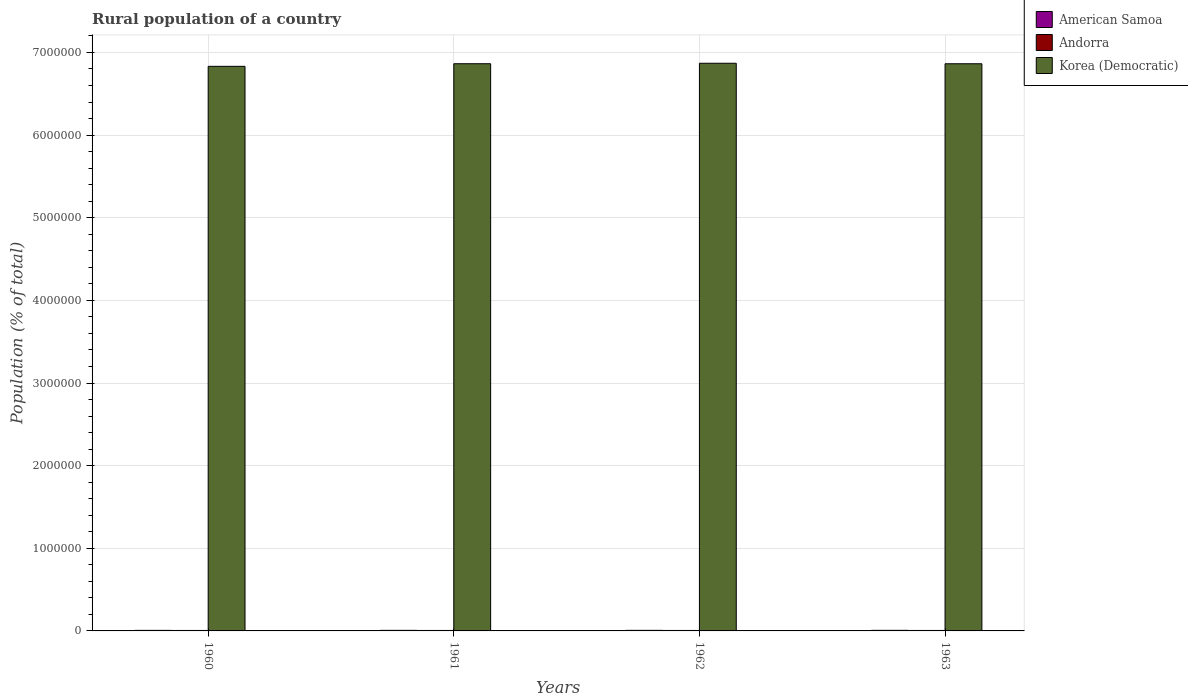How many groups of bars are there?
Provide a succinct answer. 4. Are the number of bars on each tick of the X-axis equal?
Ensure brevity in your answer.  Yes. How many bars are there on the 4th tick from the left?
Keep it short and to the point. 3. What is the label of the 1st group of bars from the left?
Provide a short and direct response. 1960. In how many cases, is the number of bars for a given year not equal to the number of legend labels?
Make the answer very short. 0. What is the rural population in Korea (Democratic) in 1963?
Provide a succinct answer. 6.86e+06. Across all years, what is the maximum rural population in Andorra?
Provide a short and direct response. 5618. Across all years, what is the minimum rural population in American Samoa?
Your answer should be compact. 6762. What is the total rural population in Andorra in the graph?
Your answer should be very brief. 2.24e+04. What is the difference between the rural population in Korea (Democratic) in 1960 and that in 1961?
Keep it short and to the point. -3.16e+04. What is the difference between the rural population in Korea (Democratic) in 1963 and the rural population in Andorra in 1960?
Keep it short and to the point. 6.86e+06. What is the average rural population in Korea (Democratic) per year?
Give a very brief answer. 6.86e+06. In the year 1962, what is the difference between the rural population in Andorra and rural population in Korea (Democratic)?
Make the answer very short. -6.86e+06. What is the ratio of the rural population in Korea (Democratic) in 1962 to that in 1963?
Make the answer very short. 1. Is the rural population in Andorra in 1960 less than that in 1963?
Provide a short and direct response. Yes. Is the difference between the rural population in Andorra in 1960 and 1963 greater than the difference between the rural population in Korea (Democratic) in 1960 and 1963?
Offer a very short reply. Yes. What is the difference between the highest and the second highest rural population in American Samoa?
Ensure brevity in your answer.  159. What is the difference between the highest and the lowest rural population in Andorra?
Offer a terse response. 44. Is the sum of the rural population in American Samoa in 1962 and 1963 greater than the maximum rural population in Korea (Democratic) across all years?
Keep it short and to the point. No. What does the 2nd bar from the left in 1963 represents?
Your response must be concise. Andorra. What does the 2nd bar from the right in 1961 represents?
Give a very brief answer. Andorra. How many bars are there?
Offer a terse response. 12. How many years are there in the graph?
Make the answer very short. 4. Does the graph contain any zero values?
Give a very brief answer. No. What is the title of the graph?
Provide a succinct answer. Rural population of a country. Does "Pacific island small states" appear as one of the legend labels in the graph?
Provide a short and direct response. No. What is the label or title of the Y-axis?
Your response must be concise. Population (% of total). What is the Population (% of total) of American Samoa in 1960?
Offer a terse response. 6762. What is the Population (% of total) of Andorra in 1960?
Give a very brief answer. 5574. What is the Population (% of total) of Korea (Democratic) in 1960?
Keep it short and to the point. 6.83e+06. What is the Population (% of total) in American Samoa in 1961?
Your response must be concise. 6831. What is the Population (% of total) of Andorra in 1961?
Your answer should be very brief. 5609. What is the Population (% of total) in Korea (Democratic) in 1961?
Offer a very short reply. 6.86e+06. What is the Population (% of total) of American Samoa in 1962?
Offer a very short reply. 6955. What is the Population (% of total) of Andorra in 1962?
Keep it short and to the point. 5618. What is the Population (% of total) in Korea (Democratic) in 1962?
Ensure brevity in your answer.  6.87e+06. What is the Population (% of total) of American Samoa in 1963?
Provide a short and direct response. 7114. What is the Population (% of total) of Andorra in 1963?
Your answer should be compact. 5600. What is the Population (% of total) in Korea (Democratic) in 1963?
Offer a very short reply. 6.86e+06. Across all years, what is the maximum Population (% of total) in American Samoa?
Offer a very short reply. 7114. Across all years, what is the maximum Population (% of total) in Andorra?
Your response must be concise. 5618. Across all years, what is the maximum Population (% of total) in Korea (Democratic)?
Keep it short and to the point. 6.87e+06. Across all years, what is the minimum Population (% of total) in American Samoa?
Keep it short and to the point. 6762. Across all years, what is the minimum Population (% of total) of Andorra?
Provide a succinct answer. 5574. Across all years, what is the minimum Population (% of total) of Korea (Democratic)?
Give a very brief answer. 6.83e+06. What is the total Population (% of total) in American Samoa in the graph?
Give a very brief answer. 2.77e+04. What is the total Population (% of total) of Andorra in the graph?
Offer a very short reply. 2.24e+04. What is the total Population (% of total) of Korea (Democratic) in the graph?
Offer a terse response. 2.74e+07. What is the difference between the Population (% of total) of American Samoa in 1960 and that in 1961?
Provide a short and direct response. -69. What is the difference between the Population (% of total) of Andorra in 1960 and that in 1961?
Your answer should be very brief. -35. What is the difference between the Population (% of total) in Korea (Democratic) in 1960 and that in 1961?
Your response must be concise. -3.16e+04. What is the difference between the Population (% of total) in American Samoa in 1960 and that in 1962?
Offer a terse response. -193. What is the difference between the Population (% of total) in Andorra in 1960 and that in 1962?
Give a very brief answer. -44. What is the difference between the Population (% of total) in Korea (Democratic) in 1960 and that in 1962?
Provide a succinct answer. -3.72e+04. What is the difference between the Population (% of total) in American Samoa in 1960 and that in 1963?
Keep it short and to the point. -352. What is the difference between the Population (% of total) in Korea (Democratic) in 1960 and that in 1963?
Your answer should be very brief. -3.11e+04. What is the difference between the Population (% of total) of American Samoa in 1961 and that in 1962?
Keep it short and to the point. -124. What is the difference between the Population (% of total) of Andorra in 1961 and that in 1962?
Make the answer very short. -9. What is the difference between the Population (% of total) of Korea (Democratic) in 1961 and that in 1962?
Offer a terse response. -5650. What is the difference between the Population (% of total) in American Samoa in 1961 and that in 1963?
Keep it short and to the point. -283. What is the difference between the Population (% of total) in Andorra in 1961 and that in 1963?
Offer a terse response. 9. What is the difference between the Population (% of total) of Korea (Democratic) in 1961 and that in 1963?
Your response must be concise. 480. What is the difference between the Population (% of total) of American Samoa in 1962 and that in 1963?
Keep it short and to the point. -159. What is the difference between the Population (% of total) of Andorra in 1962 and that in 1963?
Your answer should be very brief. 18. What is the difference between the Population (% of total) in Korea (Democratic) in 1962 and that in 1963?
Keep it short and to the point. 6130. What is the difference between the Population (% of total) of American Samoa in 1960 and the Population (% of total) of Andorra in 1961?
Give a very brief answer. 1153. What is the difference between the Population (% of total) in American Samoa in 1960 and the Population (% of total) in Korea (Democratic) in 1961?
Give a very brief answer. -6.86e+06. What is the difference between the Population (% of total) in Andorra in 1960 and the Population (% of total) in Korea (Democratic) in 1961?
Your answer should be compact. -6.86e+06. What is the difference between the Population (% of total) of American Samoa in 1960 and the Population (% of total) of Andorra in 1962?
Ensure brevity in your answer.  1144. What is the difference between the Population (% of total) of American Samoa in 1960 and the Population (% of total) of Korea (Democratic) in 1962?
Your response must be concise. -6.86e+06. What is the difference between the Population (% of total) of Andorra in 1960 and the Population (% of total) of Korea (Democratic) in 1962?
Provide a short and direct response. -6.86e+06. What is the difference between the Population (% of total) of American Samoa in 1960 and the Population (% of total) of Andorra in 1963?
Provide a short and direct response. 1162. What is the difference between the Population (% of total) of American Samoa in 1960 and the Population (% of total) of Korea (Democratic) in 1963?
Offer a very short reply. -6.86e+06. What is the difference between the Population (% of total) of Andorra in 1960 and the Population (% of total) of Korea (Democratic) in 1963?
Offer a very short reply. -6.86e+06. What is the difference between the Population (% of total) of American Samoa in 1961 and the Population (% of total) of Andorra in 1962?
Your answer should be compact. 1213. What is the difference between the Population (% of total) in American Samoa in 1961 and the Population (% of total) in Korea (Democratic) in 1962?
Ensure brevity in your answer.  -6.86e+06. What is the difference between the Population (% of total) in Andorra in 1961 and the Population (% of total) in Korea (Democratic) in 1962?
Keep it short and to the point. -6.86e+06. What is the difference between the Population (% of total) of American Samoa in 1961 and the Population (% of total) of Andorra in 1963?
Ensure brevity in your answer.  1231. What is the difference between the Population (% of total) of American Samoa in 1961 and the Population (% of total) of Korea (Democratic) in 1963?
Your answer should be very brief. -6.86e+06. What is the difference between the Population (% of total) in Andorra in 1961 and the Population (% of total) in Korea (Democratic) in 1963?
Ensure brevity in your answer.  -6.86e+06. What is the difference between the Population (% of total) in American Samoa in 1962 and the Population (% of total) in Andorra in 1963?
Your answer should be compact. 1355. What is the difference between the Population (% of total) of American Samoa in 1962 and the Population (% of total) of Korea (Democratic) in 1963?
Offer a terse response. -6.86e+06. What is the difference between the Population (% of total) in Andorra in 1962 and the Population (% of total) in Korea (Democratic) in 1963?
Provide a short and direct response. -6.86e+06. What is the average Population (% of total) in American Samoa per year?
Offer a terse response. 6915.5. What is the average Population (% of total) in Andorra per year?
Provide a succinct answer. 5600.25. What is the average Population (% of total) of Korea (Democratic) per year?
Provide a succinct answer. 6.86e+06. In the year 1960, what is the difference between the Population (% of total) in American Samoa and Population (% of total) in Andorra?
Give a very brief answer. 1188. In the year 1960, what is the difference between the Population (% of total) in American Samoa and Population (% of total) in Korea (Democratic)?
Provide a succinct answer. -6.83e+06. In the year 1960, what is the difference between the Population (% of total) of Andorra and Population (% of total) of Korea (Democratic)?
Provide a succinct answer. -6.83e+06. In the year 1961, what is the difference between the Population (% of total) in American Samoa and Population (% of total) in Andorra?
Provide a succinct answer. 1222. In the year 1961, what is the difference between the Population (% of total) of American Samoa and Population (% of total) of Korea (Democratic)?
Make the answer very short. -6.86e+06. In the year 1961, what is the difference between the Population (% of total) in Andorra and Population (% of total) in Korea (Democratic)?
Your response must be concise. -6.86e+06. In the year 1962, what is the difference between the Population (% of total) in American Samoa and Population (% of total) in Andorra?
Your answer should be very brief. 1337. In the year 1962, what is the difference between the Population (% of total) of American Samoa and Population (% of total) of Korea (Democratic)?
Provide a succinct answer. -6.86e+06. In the year 1962, what is the difference between the Population (% of total) of Andorra and Population (% of total) of Korea (Democratic)?
Provide a short and direct response. -6.86e+06. In the year 1963, what is the difference between the Population (% of total) of American Samoa and Population (% of total) of Andorra?
Ensure brevity in your answer.  1514. In the year 1963, what is the difference between the Population (% of total) in American Samoa and Population (% of total) in Korea (Democratic)?
Provide a succinct answer. -6.86e+06. In the year 1963, what is the difference between the Population (% of total) of Andorra and Population (% of total) of Korea (Democratic)?
Offer a terse response. -6.86e+06. What is the ratio of the Population (% of total) of American Samoa in 1960 to that in 1961?
Provide a short and direct response. 0.99. What is the ratio of the Population (% of total) of Andorra in 1960 to that in 1961?
Make the answer very short. 0.99. What is the ratio of the Population (% of total) in American Samoa in 1960 to that in 1962?
Provide a short and direct response. 0.97. What is the ratio of the Population (% of total) of American Samoa in 1960 to that in 1963?
Keep it short and to the point. 0.95. What is the ratio of the Population (% of total) in Andorra in 1960 to that in 1963?
Ensure brevity in your answer.  1. What is the ratio of the Population (% of total) in Korea (Democratic) in 1960 to that in 1963?
Your answer should be very brief. 1. What is the ratio of the Population (% of total) in American Samoa in 1961 to that in 1962?
Provide a succinct answer. 0.98. What is the ratio of the Population (% of total) of Andorra in 1961 to that in 1962?
Make the answer very short. 1. What is the ratio of the Population (% of total) of American Samoa in 1961 to that in 1963?
Give a very brief answer. 0.96. What is the ratio of the Population (% of total) in Andorra in 1961 to that in 1963?
Give a very brief answer. 1. What is the ratio of the Population (% of total) of Korea (Democratic) in 1961 to that in 1963?
Ensure brevity in your answer.  1. What is the ratio of the Population (% of total) of American Samoa in 1962 to that in 1963?
Provide a short and direct response. 0.98. What is the ratio of the Population (% of total) in Andorra in 1962 to that in 1963?
Provide a succinct answer. 1. What is the difference between the highest and the second highest Population (% of total) of American Samoa?
Keep it short and to the point. 159. What is the difference between the highest and the second highest Population (% of total) in Andorra?
Provide a succinct answer. 9. What is the difference between the highest and the second highest Population (% of total) in Korea (Democratic)?
Your answer should be very brief. 5650. What is the difference between the highest and the lowest Population (% of total) in American Samoa?
Your response must be concise. 352. What is the difference between the highest and the lowest Population (% of total) of Korea (Democratic)?
Your response must be concise. 3.72e+04. 